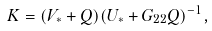Convert formula to latex. <formula><loc_0><loc_0><loc_500><loc_500>K = ( V _ { * } + Q ) ( U _ { * } + G _ { 2 2 } Q ) ^ { - 1 } ,</formula> 